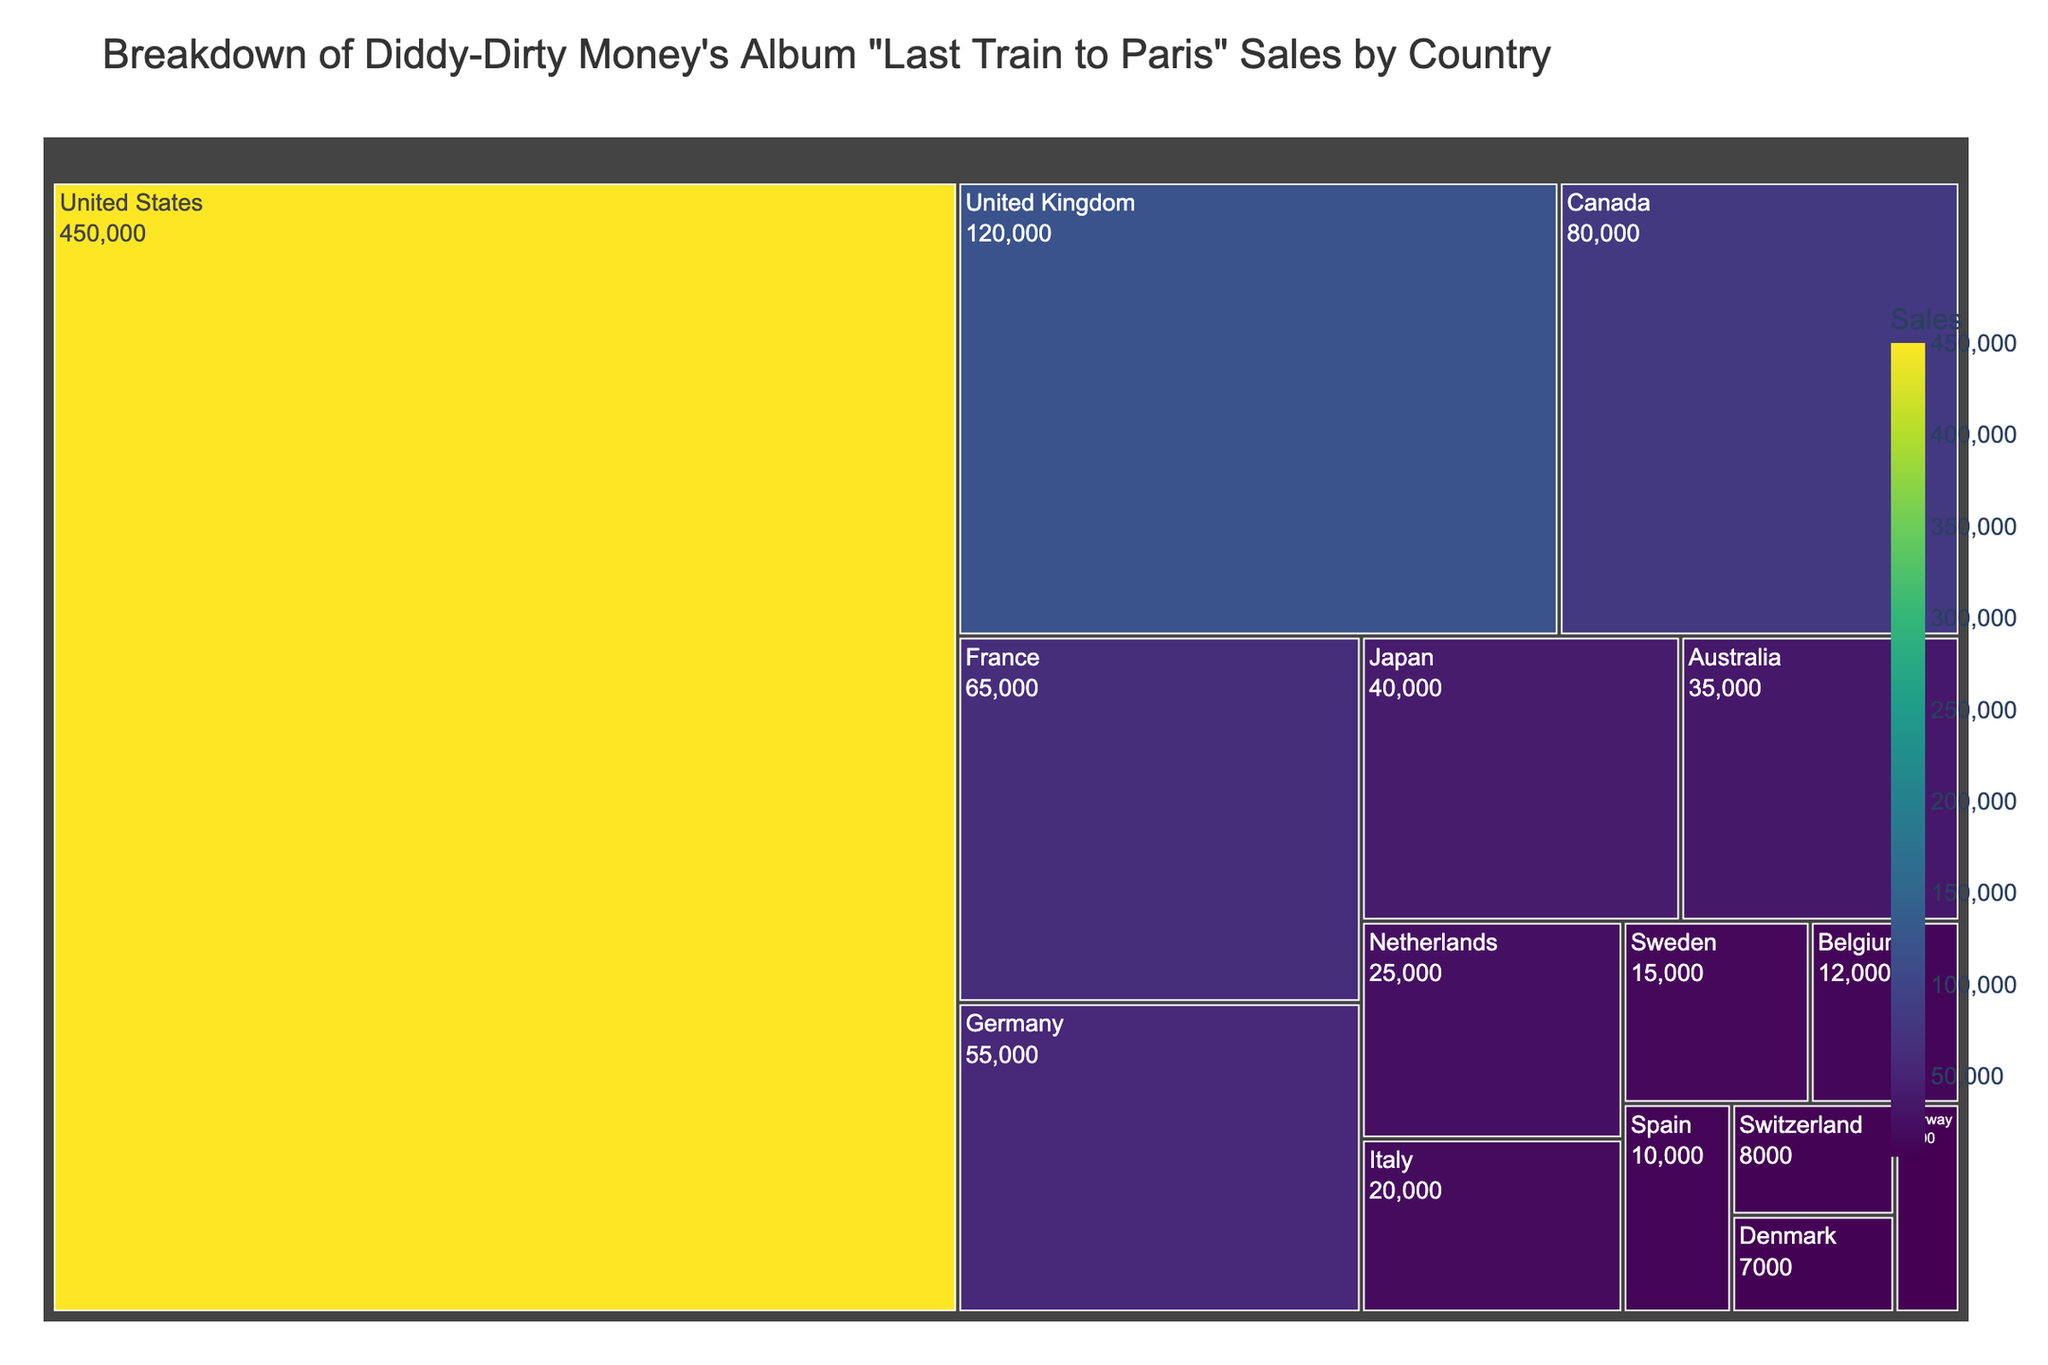What is the title of the Treemap? The title is displayed at the top of the Treemap and is typically formatted in a larger font size, making it easily identifiable.
Answer: Breakdown of Diddy-Dirty Money's Album "Last Train to Paris" Sales by Country Which country has the highest album sales? The Treemap visually represents the size of sales with larger blocks indicating higher sales. Look for the largest block.
Answer: United States How many countries have album sales less than 10,000? Identify the blocks that represent countries with sales figures less than 10,000 and count them.
Answer: Three What is the combined album sales total for Canada and France? Locate the blocks for Canada and France, sum their sales figures: 80,000 (Canada) + 65,000 (France).
Answer: 145,000 Which country has higher album sales, Germany or Japan? Compare the blocks for Germany and Japan to determine which has higher sales.
Answer: Germany What percentage of total album sales come from the United States? Calculate the United States sales (450,000) divided by the sum of the total sales across all countries and multiply by 100.
Answer: ~54% How many countries have album sales between 20,000 and 50,000? Identify the blocks representing countries with sales between 20,000 and 50,000 and count them.
Answer: Five What is the average album sales per country? Sum the total sales of all countries and divide by the number of countries. Total sales = 957,000; Number of countries = 15; Average = 957,000 / 15.
Answer: 63,800 Which European country has the lowest album sales? Among the European countries, identify the block with the smallest size and sales figure.
Answer: Norway Among Australia, Netherlands, and Belgium, which country has the lowest album sales? Compare the sales figures for Australia (35,000), Netherlands (25,000), and Belgium (12,000).
Answer: Belgium 